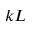Convert formula to latex. <formula><loc_0><loc_0><loc_500><loc_500>k L</formula> 